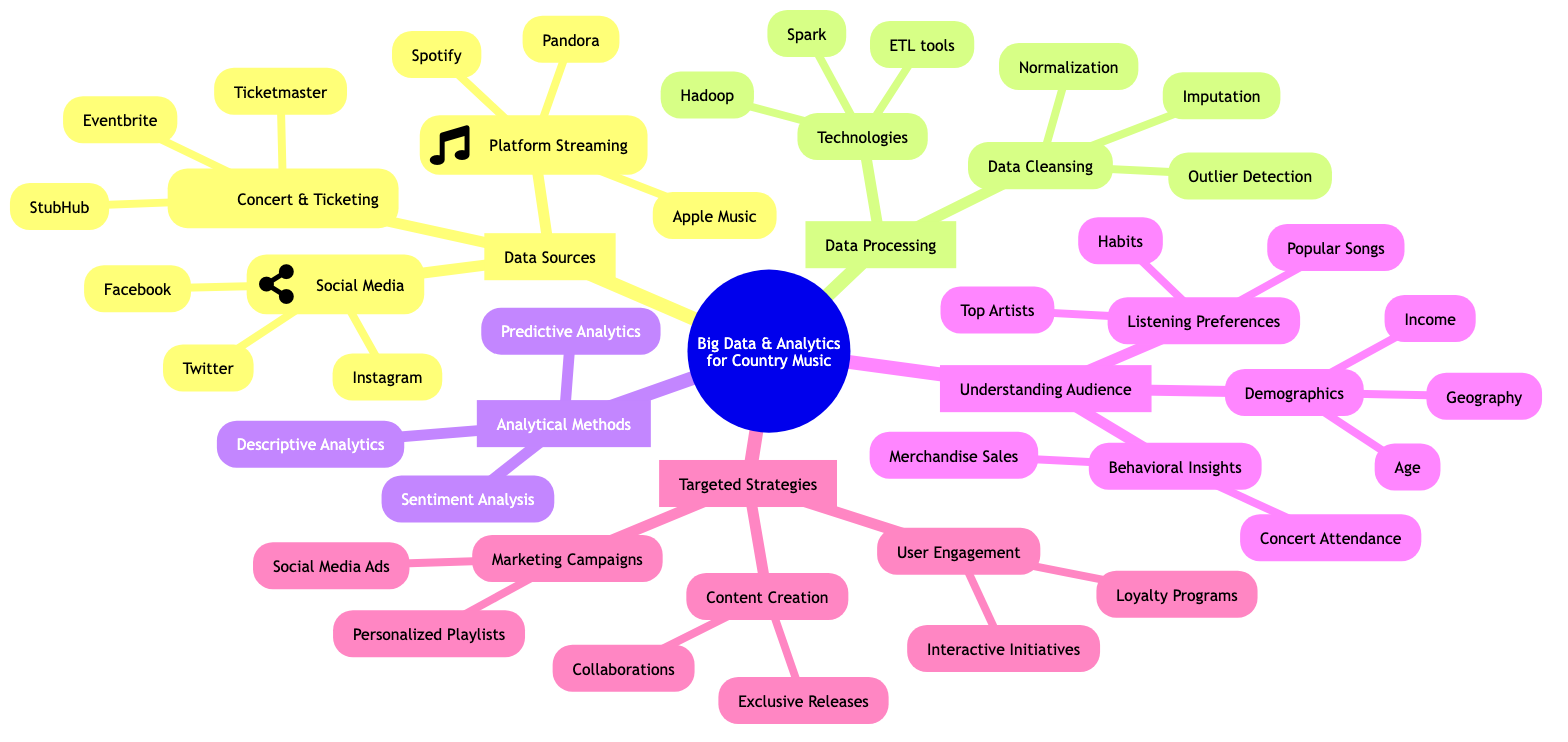What are three examples of platform streaming data? The subcomponent "Platform Streaming Data" under "Data Sources" lists "Spotify," "Apple Music," and "Pandora" as examples. Therefore, the answer comes directly from the examples in this section.
Answer: Spotify, Apple Music, Pandora How many subcomponents are listed under "Utilizing Big Data and Analytics"? The main component "Utilizing Big Data and Analytics" has three subcomponents: "Data Sources," "Data Processing," "Analytical Methods," "Understanding Audience," and "Targeted Strategies," totaling five. Counting these gives us the answer.
Answer: 5 What is one type of demographic segmentation described? Under "Understanding Audience" and specifically in "Demographic Segmentation," "Age" is mentioned as a category, which includes "Teens," "Adults," and "Seniors." This indicates the focus on various age groups.
Answer: Age What are two data cleansing techniques mentioned? In the "Data Processing" section, under "Data Cleansing," the techniques listed are "Data Imputation," "Outlier Detection," and "Normalization." Selecting any two of these represents an answer.
Answer: Data Imputation, Outlier Detection Which two platforms are used for social media data? The "Social Media Data" section lists "Facebook," "Instagram," and "Twitter." From this, I can choose any two for the answer, as they are all examples given in that category.
Answer: Facebook, Instagram How do "Personalized Playlists" serve as a marketing campaign strategy? "Personalized Playlists" is a specific example mentioned under "Marketing Campaigns." It is a strategy that utilizes user data to create custom playlists, enhancing listener engagement and satisfaction, indicating how technology meets audience preferences.
Answer: Enhance listener engagement What are the listening preferences categorized under? In the "Understanding Audience" section, "Listening Preferences" is one of the categories that considers aspects like "Top Artists," "Popular Songs," and "Listening Habits," illustrating how audience preferences are structured.
Answer: Top Artists, Popular Songs, Listening Habits How does sentiment analysis contribute to understanding audience preferences? Sentiment Analysis includes techniques like "Natural Language Processing" and "Text Mining" under "Analytical Methods." These methods help gauge audience feelings and attitudes toward music, enabling tailored content and marketing efforts.
Answer: Gauge audience feelings What is the relationship between "Concert Attendance" and "Merchandise Sales"? Both are listed under "Behavioral Insights," which falls under the "Understanding Audience" main category. They are parallel components that provide insights into audience behavior, illustrating how attendee engagement relates to sales patterns.
Answer: Parallel components in Behavioral Insights 